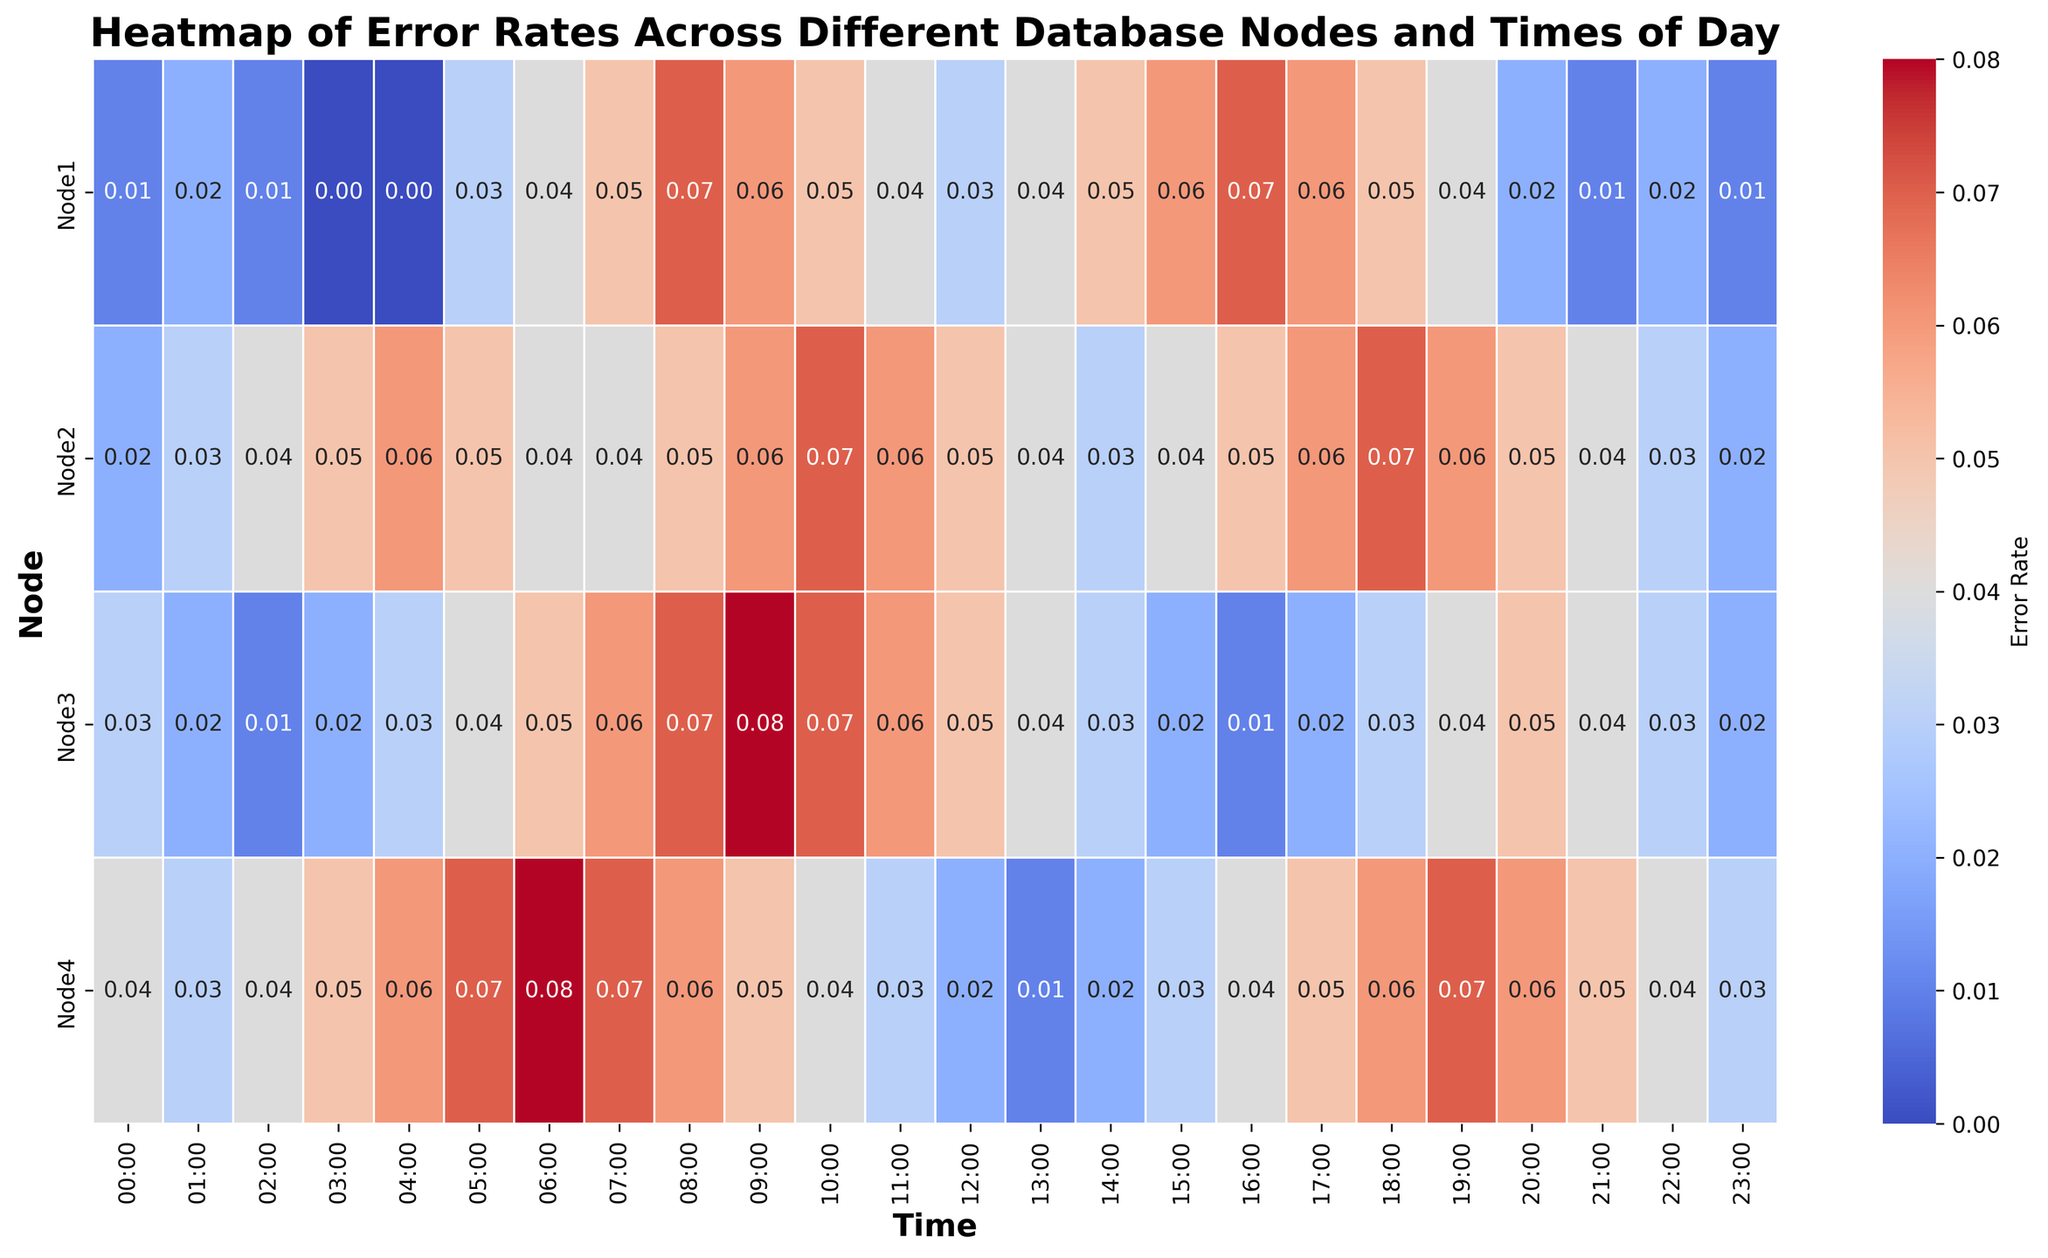What's the time of day with the peak error rate for Node1? Locate Node1 on the y-axis and scan across the x-axis to find the highest value, which is 0.07 at 08:00 and 16:00.
Answer: 08:00 and 16:00 Which node has the highest average error rate across the entire day? Calculate the average error rate for each node by summing the error rates for each hour and dividing by 24. Node4's rates sum up to the highest value.
Answer: Node4 What's the difference in error rate between Node2 at 10:00 and Node3 at the same time? Node2 has an error rate of 0.07 at 10:00, and Node3 has 0.07. The difference is 0.07 - 0.07.
Answer: 0.00 Which node has the lowest error rate at 18:00? Compare the error rates of all nodes at 18:00—Node1 (0.05), Node2 (0.07), Node3 (0.03), and Node4 (0.06). Node3 has the lowest error rate.
Answer: Node3 At what time does Node3 experience its highest error rate? Scan the hours for Node3 and identify the highest error rate value, which is 0.08 at 09:00.
Answer: 09:00 What's the average error rate for Node1 between 12:00 and 18:00? Add the error rates for Node1 from 12:00 to 18:00 (0.03 + 0.04 + 0.05 + 0.06 + 0.07 + 0.06 + 0.05), then divide by 7. The sum is 0.36, so 0.36 / 7.
Answer: 0.0514 Which two nodes have the most similar error rates at 04:00? Compare the error rates for all nodes at 04:00. Node1 and Node3 both have close values (0.00 and 0.03). Node2 and Node4 both have 0.06.
Answer: Node2 and Node4 What is the median error rate for Node2 across the entire day? List all the error rates for Node2, sort them (0.02, 0.03, 0.03, 0.04, 0.04, 0.04, 0.05, 0.05, 0.05, 0.05, 0.06, 0.06, 0.06, 0.06, 0.06, 0.06, 0.06, 0.07, 0.07), and find the middle value which is 0.05.
Answer: 0.05 Identify a node and time combination where the error rate is exactly 0.01. Node1 at 00:00, 02:00, 21:00, and 23:00 all have an error rate of 0.01.
Answer: Node1 at 00:00, 02:00, 21:00, and 23:00 